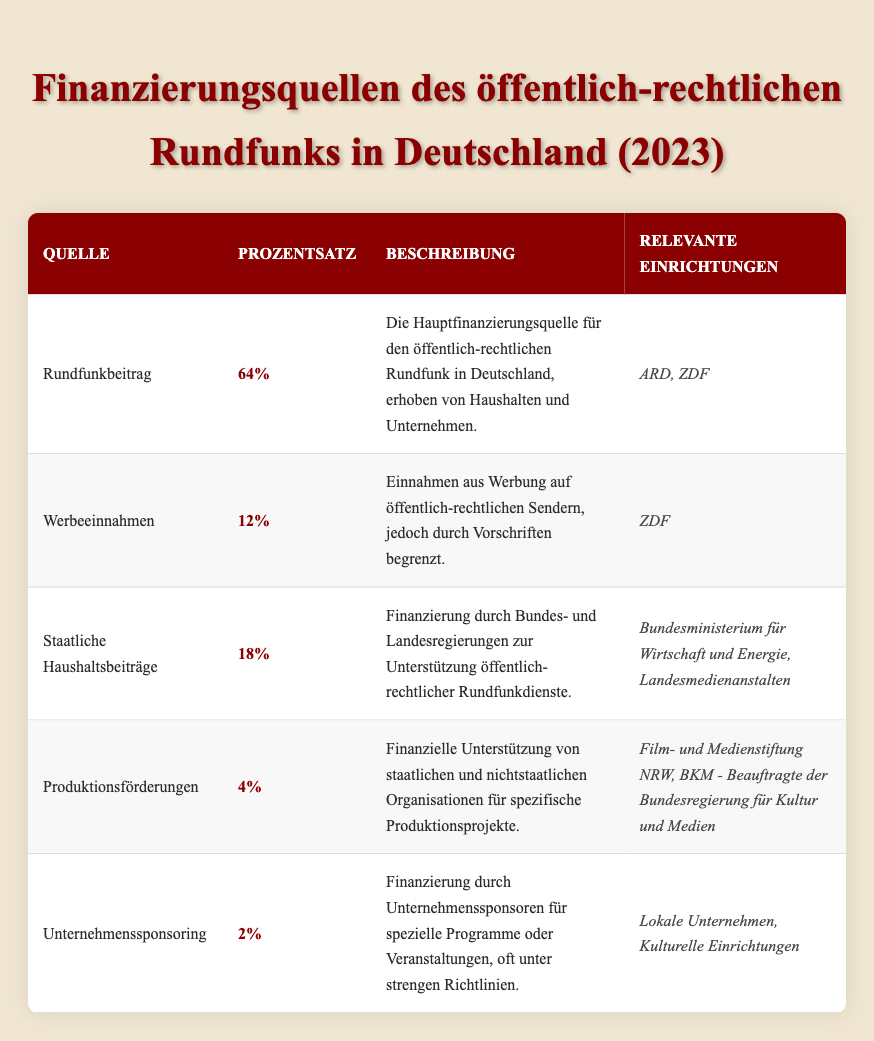What is the main source of funding for public broadcasting in Germany? The table indicates that the main source of funding is the Licence Fee, which accounts for 64% of the total funding sources.
Answer: Licence Fee What percentage of funding comes from Corporate Sponsorship? The table lists the percentage for Corporate Sponsorship as 2%.
Answer: 2% Do both ARD and ZDF receive income from the Licence Fee? Yes, according to the table, both ARD and ZDF are relevant entities benefiting from the Licence Fee.
Answer: Yes How much does total funding from State Budget Contributions and Production Grants amount to? The State Budget Contributions account for 18% and Production Grants for 4%. Summing these gives 18% + 4% = 22%.
Answer: 22% Is the percentage of funding from Advertising Revenue greater than that from Production Grants? Yes, Advertising Revenue is 12% while Production Grants are only 4%, hence 12% is greater than 4%.
Answer: Yes What is the combined percentage of funding from Licence Fee and Advertising Revenue? The Licence Fee is 64% and Advertising Revenue is 12%. Adding these gives 64% + 12% = 76%.
Answer: 76% Which funding source has the least percentage, and what is that percentage? From the table, Corporate Sponsorship has the least percentage at 2%.
Answer: Corporate Sponsorship, 2% What percentage of funding is represented by sources other than the Licence Fee? The total percentage from other sources (Advertising Revenue, State Budget Contributions, Production Grants, and Corporate Sponsorship) is 12% + 18% + 4% + 2% = 36%.
Answer: 36% Are the relevant entities for Production Grants limited to governmental organizations? No, the relevant entities also include non-governmental organizations as per the description in the table.
Answer: No 